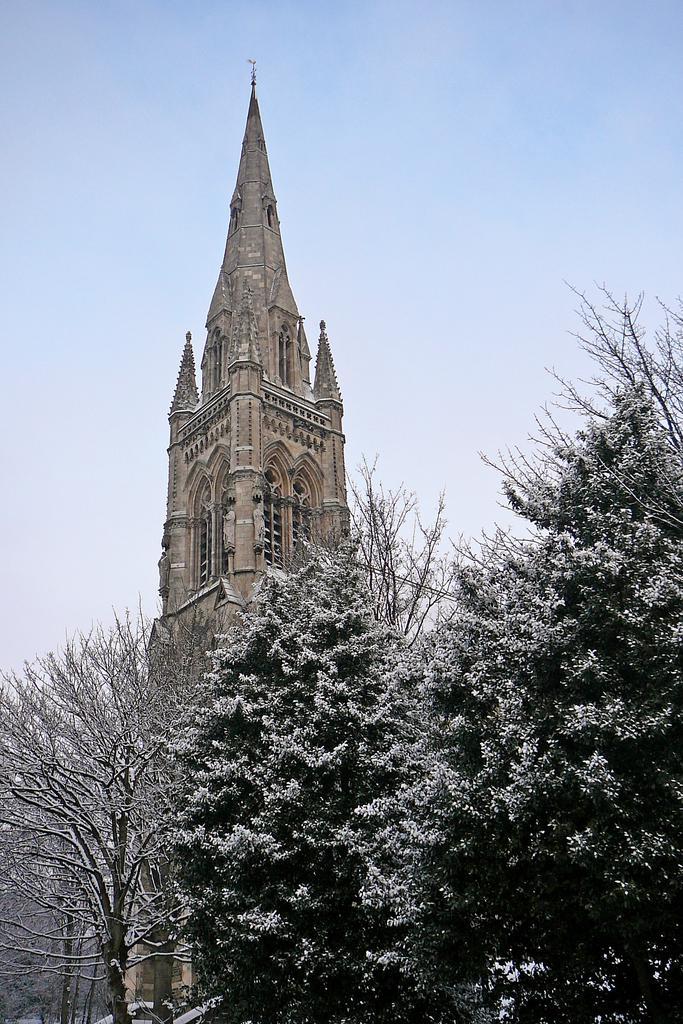Could you give a brief overview of what you see in this image? There are trees. In the back there is a building with windows. In the background there is sky. 